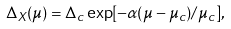Convert formula to latex. <formula><loc_0><loc_0><loc_500><loc_500>\Delta _ { X } ( \mu ) = \Delta _ { c } \exp [ - \alpha ( \mu - \mu _ { c } ) / \mu _ { c } ] ,</formula> 